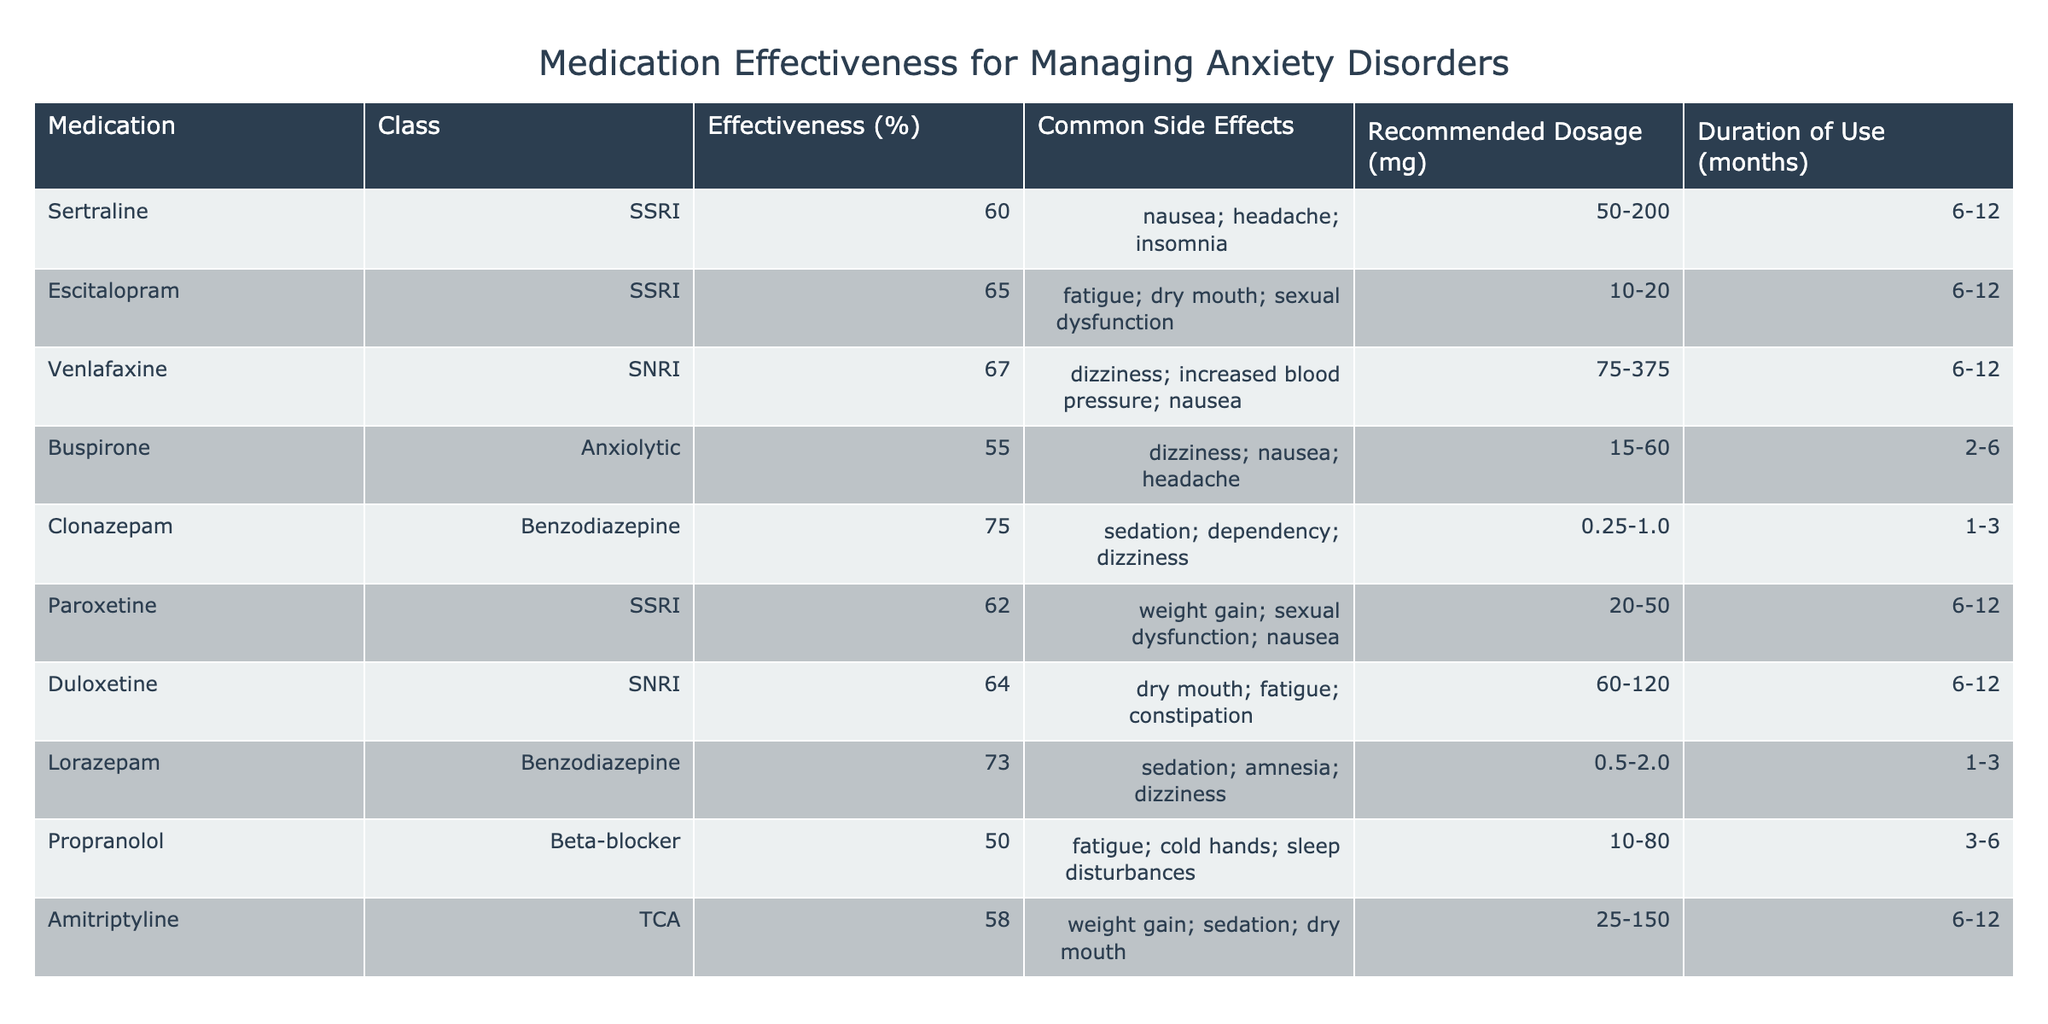What is the effectiveness percentage of Clonazepam? Clonazepam has an effectiveness percentage listed in the table. By locating the row for Clonazepam under the "Effectiveness (%)" column, we see that it states 75%.
Answer: 75% Which medication has the lowest effectiveness percentage for managing anxiety disorders? Reviewing the effectiveness percentages from the table, we find that Propranolol has the lowest effectiveness at 50%. We compare all values, and Propranolol is the least.
Answer: Propranolol What are the common side effects associated with Venlafaxine? The table lists the common side effects for each medication. For Venlafaxine, it states the side effects are dizziness, increased blood pressure, and nausea.
Answer: dizziness; increased blood pressure; nausea Is Buspirone considered to be more effective than Sertraline? To determine this, we compare the effectiveness percentages of each medication. Buspirone has 55% effectiveness while Sertraline has 60%. Since 55% is less than 60%, Buspirone is not more effective than Sertraline.
Answer: No What is the average effectiveness percentage of the SSRIs listed? The SSRIs in the table are Sertraline, Escitalopram, Paroxetine, and Duloxetine, with effectiveness percentages of 60%, 65%, 62%, and 64%, respectively. We sum these values (60 + 65 + 62 + 64 = 251) and divide by the number of SSRIs (4). The average is 251/4 = 62.75%.
Answer: 62.75% Which medication has the highest recommended dosage range? By examining the "Recommended Dosage (mg)" column, we see that Venlafaxine has the highest range, from 75 to 375 mg. Comparing all dosage ranges, this is the largest.
Answer: Venlafaxine If a patient has a history of sedation as a side effect, which two medications should they avoid? From the table, the medications with sedation listed as a common side effect are Clonazepam and Lorazepam. We identify both and conclude that they should be avoided by patients with that history.
Answer: Clonazepam and Lorazepam What is the maximum duration of use for Buspirone? Looking at the "Duration of Use (months)" column, Buspirone has a maximum duration of 6 months. This is the information in the corresponding row.
Answer: 6 months How many medications have an effectiveness percentage greater than 60%? We evaluate each medication's effectiveness percentage, identifying that Sertraline (60%), Escitalopram (65%), Venlafaxine (67%), Clonazepam (75%), Paroxetine (62%), and Duloxetine (64%) all have values greater than 60%. This totals to 6 medications.
Answer: 6 